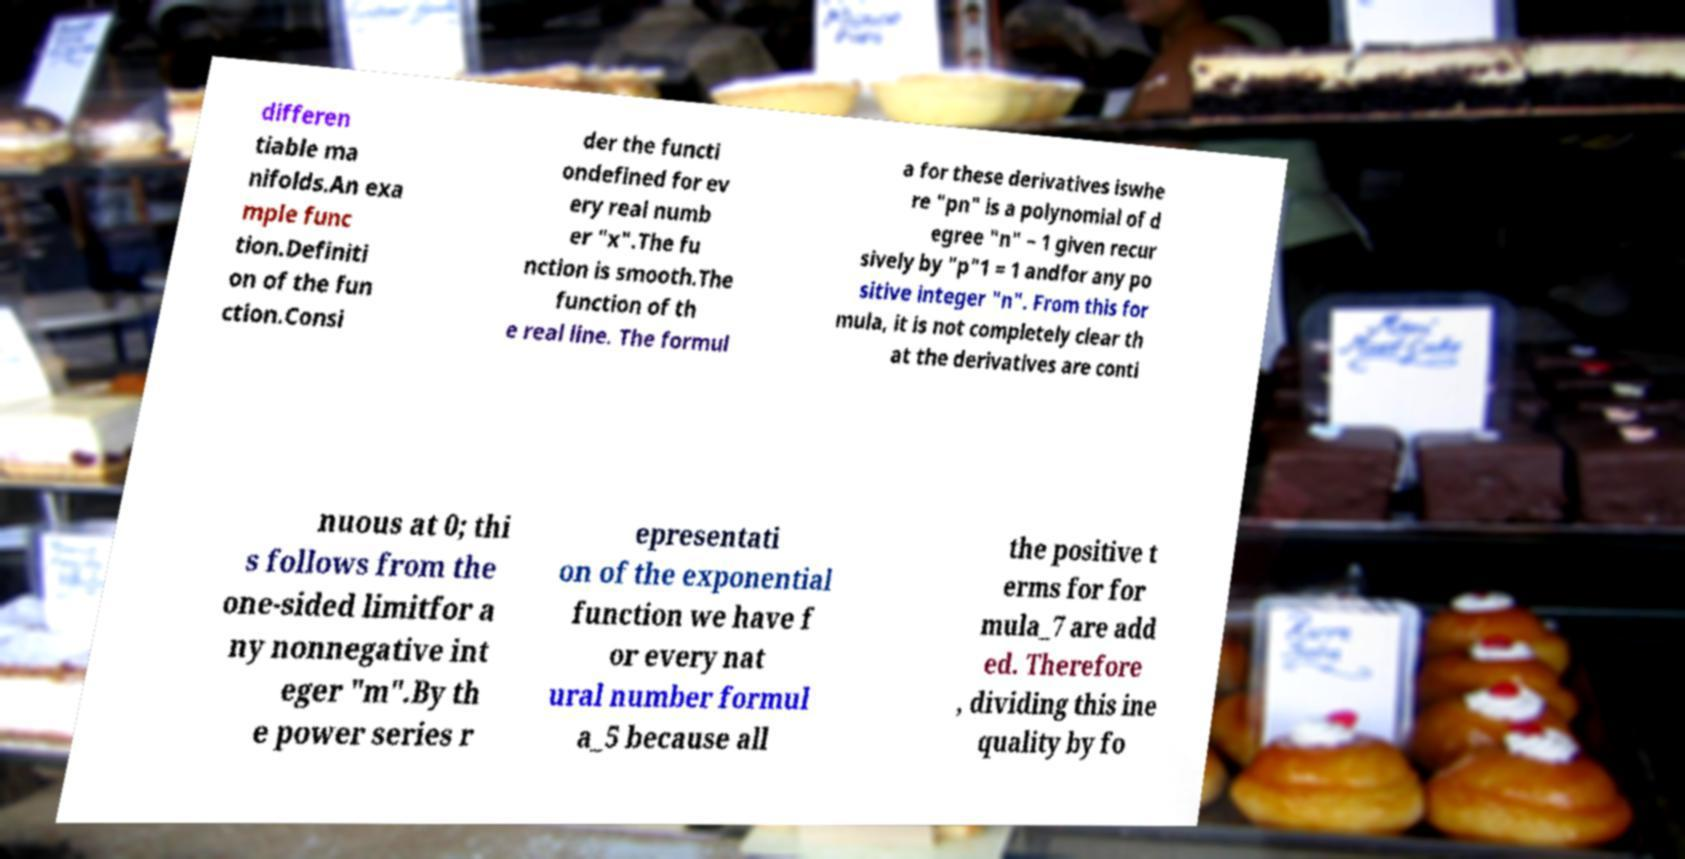I need the written content from this picture converted into text. Can you do that? differen tiable ma nifolds.An exa mple func tion.Definiti on of the fun ction.Consi der the functi ondefined for ev ery real numb er "x".The fu nction is smooth.The function of th e real line. The formul a for these derivatives iswhe re "pn" is a polynomial of d egree "n" − 1 given recur sively by "p"1 = 1 andfor any po sitive integer "n". From this for mula, it is not completely clear th at the derivatives are conti nuous at 0; thi s follows from the one-sided limitfor a ny nonnegative int eger "m".By th e power series r epresentati on of the exponential function we have f or every nat ural number formul a_5 because all the positive t erms for for mula_7 are add ed. Therefore , dividing this ine quality by fo 